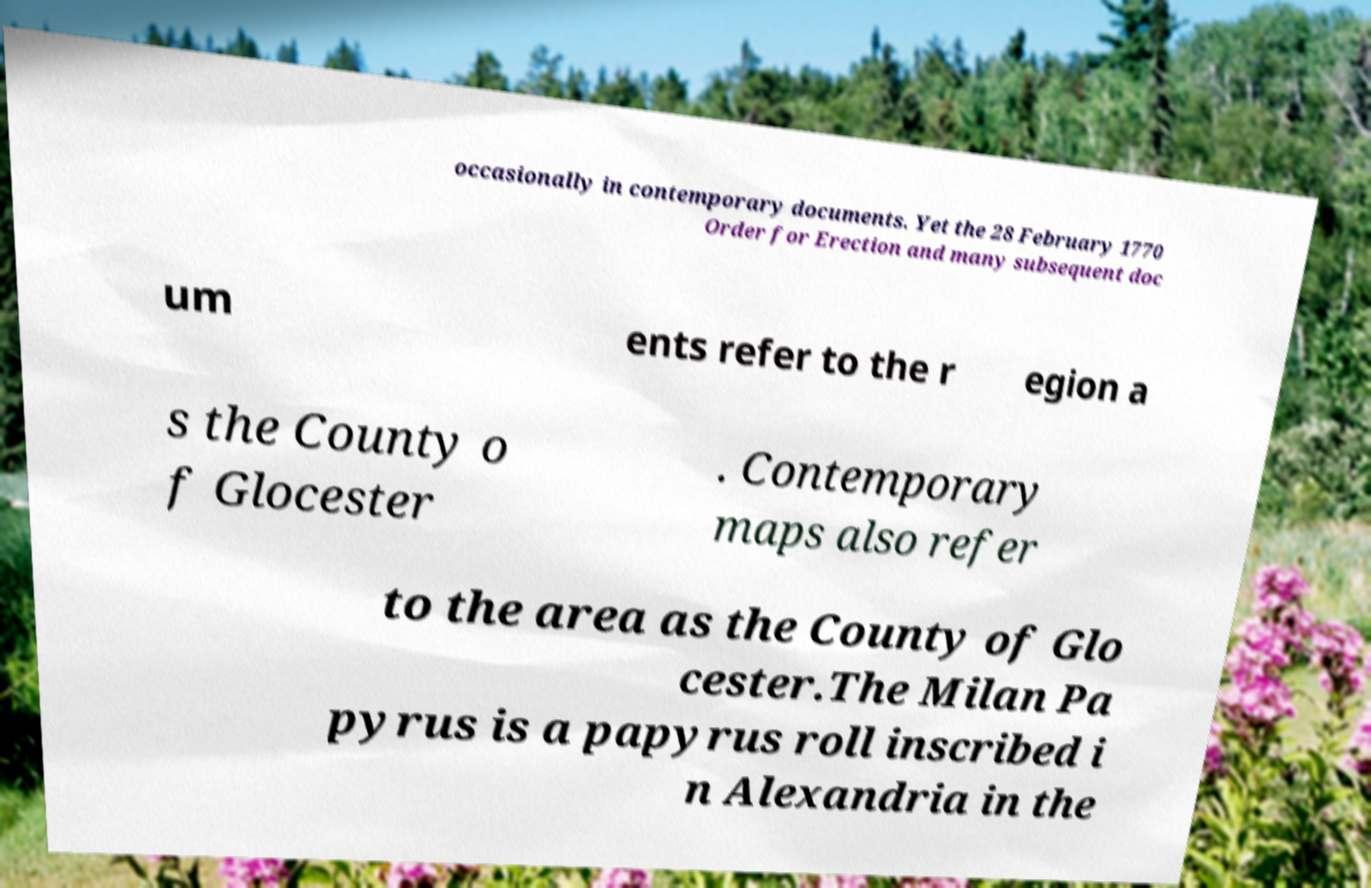Please read and relay the text visible in this image. What does it say? occasionally in contemporary documents. Yet the 28 February 1770 Order for Erection and many subsequent doc um ents refer to the r egion a s the County o f Glocester . Contemporary maps also refer to the area as the County of Glo cester.The Milan Pa pyrus is a papyrus roll inscribed i n Alexandria in the 